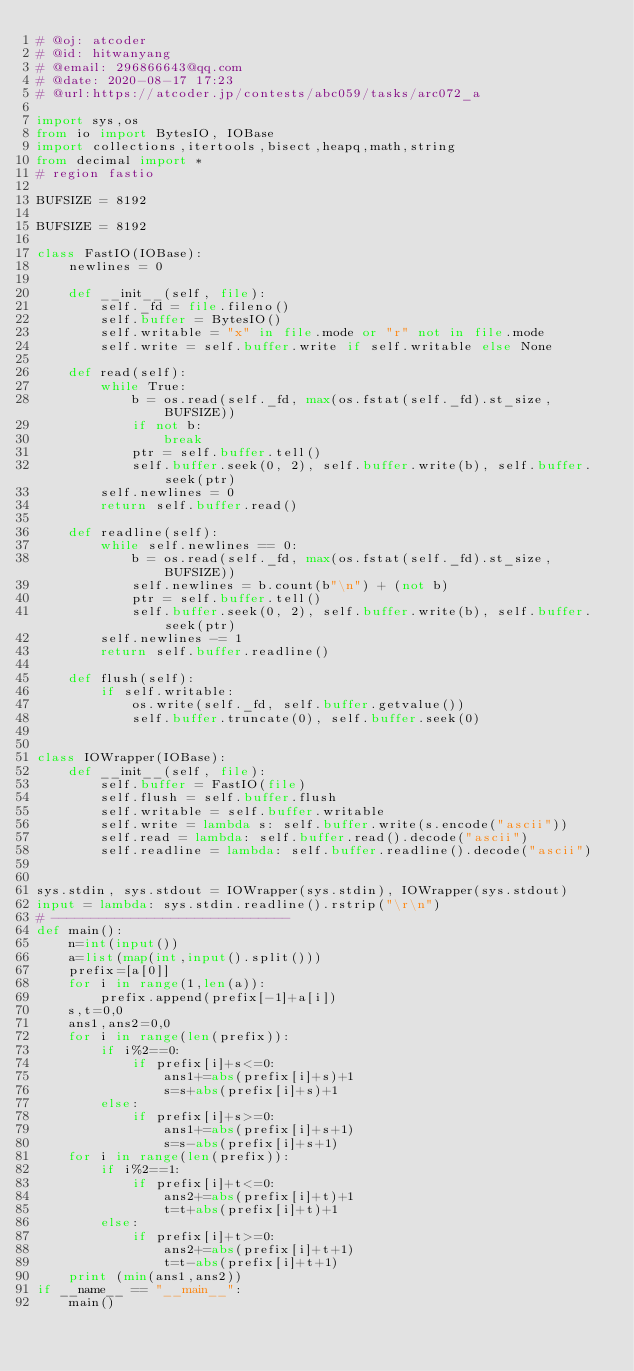<code> <loc_0><loc_0><loc_500><loc_500><_Python_># @oj: atcoder
# @id: hitwanyang
# @email: 296866643@qq.com
# @date: 2020-08-17 17:23
# @url:https://atcoder.jp/contests/abc059/tasks/arc072_a

import sys,os
from io import BytesIO, IOBase
import collections,itertools,bisect,heapq,math,string
from decimal import *
# region fastio

BUFSIZE = 8192

BUFSIZE = 8192

class FastIO(IOBase):
    newlines = 0

    def __init__(self, file):
        self._fd = file.fileno()
        self.buffer = BytesIO()
        self.writable = "x" in file.mode or "r" not in file.mode
        self.write = self.buffer.write if self.writable else None

    def read(self):
        while True:
            b = os.read(self._fd, max(os.fstat(self._fd).st_size, BUFSIZE))
            if not b:
                break
            ptr = self.buffer.tell()
            self.buffer.seek(0, 2), self.buffer.write(b), self.buffer.seek(ptr)
        self.newlines = 0
        return self.buffer.read()

    def readline(self):
        while self.newlines == 0:
            b = os.read(self._fd, max(os.fstat(self._fd).st_size, BUFSIZE))
            self.newlines = b.count(b"\n") + (not b)
            ptr = self.buffer.tell()
            self.buffer.seek(0, 2), self.buffer.write(b), self.buffer.seek(ptr)
        self.newlines -= 1
        return self.buffer.readline()

    def flush(self):
        if self.writable:
            os.write(self._fd, self.buffer.getvalue())
            self.buffer.truncate(0), self.buffer.seek(0)


class IOWrapper(IOBase):
    def __init__(self, file):
        self.buffer = FastIO(file)
        self.flush = self.buffer.flush
        self.writable = self.buffer.writable
        self.write = lambda s: self.buffer.write(s.encode("ascii"))
        self.read = lambda: self.buffer.read().decode("ascii")
        self.readline = lambda: self.buffer.readline().decode("ascii")


sys.stdin, sys.stdout = IOWrapper(sys.stdin), IOWrapper(sys.stdout)
input = lambda: sys.stdin.readline().rstrip("\r\n")
# ------------------------------
def main():
    n=int(input())
    a=list(map(int,input().split()))
    prefix=[a[0]]
    for i in range(1,len(a)):
        prefix.append(prefix[-1]+a[i])
    s,t=0,0
    ans1,ans2=0,0
    for i in range(len(prefix)):
        if i%2==0:
            if prefix[i]+s<=0:
                ans1+=abs(prefix[i]+s)+1
                s=s+abs(prefix[i]+s)+1
        else:
            if prefix[i]+s>=0:
                ans1+=abs(prefix[i]+s+1)
                s=s-abs(prefix[i]+s+1)
    for i in range(len(prefix)):
        if i%2==1:
            if prefix[i]+t<=0:
                ans2+=abs(prefix[i]+t)+1
                t=t+abs(prefix[i]+t)+1
        else:
            if prefix[i]+t>=0:
                ans2+=abs(prefix[i]+t+1)
                t=t-abs(prefix[i]+t+1)
    print (min(ans1,ans2))
if __name__ == "__main__":
    main()</code> 